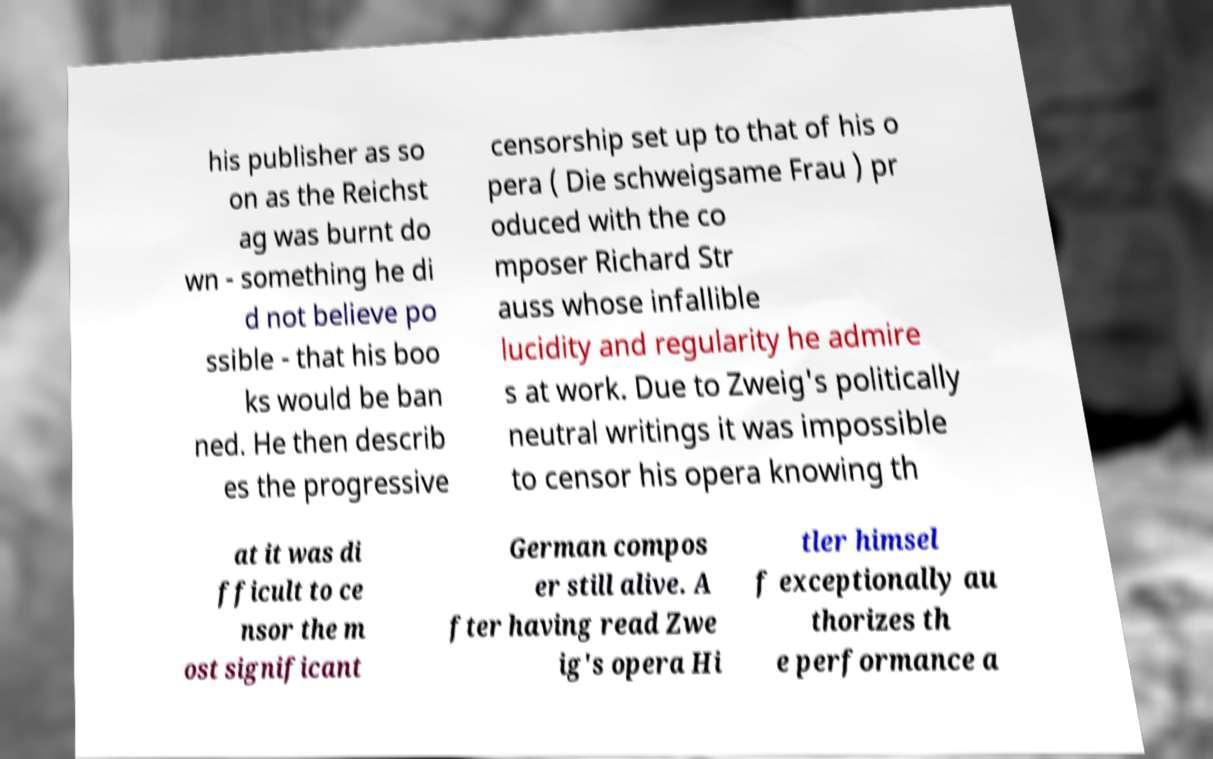Could you assist in decoding the text presented in this image and type it out clearly? his publisher as so on as the Reichst ag was burnt do wn - something he di d not believe po ssible - that his boo ks would be ban ned. He then describ es the progressive censorship set up to that of his o pera ( Die schweigsame Frau ) pr oduced with the co mposer Richard Str auss whose infallible lucidity and regularity he admire s at work. Due to Zweig's politically neutral writings it was impossible to censor his opera knowing th at it was di fficult to ce nsor the m ost significant German compos er still alive. A fter having read Zwe ig's opera Hi tler himsel f exceptionally au thorizes th e performance a 